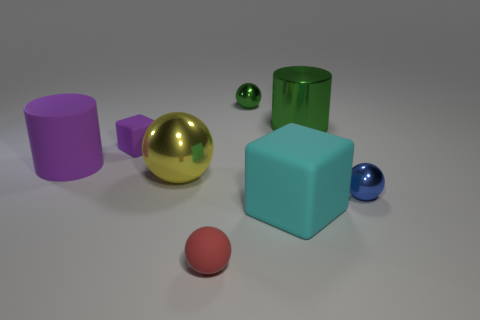Subtract 1 spheres. How many spheres are left? 3 Subtract all small spheres. How many spheres are left? 1 Add 1 small yellow metallic things. How many objects exist? 9 Subtract all brown balls. Subtract all red cubes. How many balls are left? 4 Subtract all blocks. How many objects are left? 6 Add 2 brown cubes. How many brown cubes exist? 2 Subtract 1 blue spheres. How many objects are left? 7 Subtract all red rubber spheres. Subtract all big purple objects. How many objects are left? 6 Add 6 small red balls. How many small red balls are left? 7 